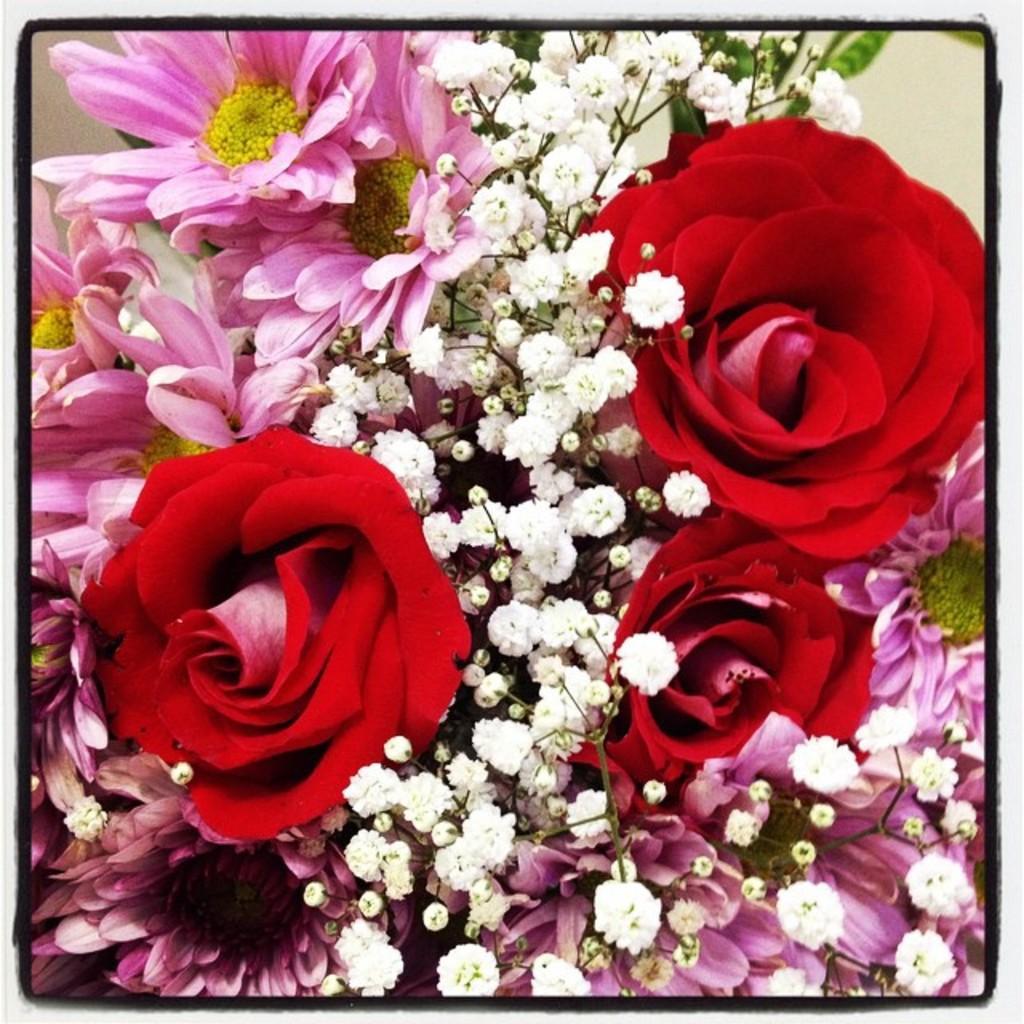Please provide a concise description of this image. In this image I can see flowering plants, buds and wall. This image looks like a photo frame. 